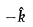Convert formula to latex. <formula><loc_0><loc_0><loc_500><loc_500>- \hat { k }</formula> 